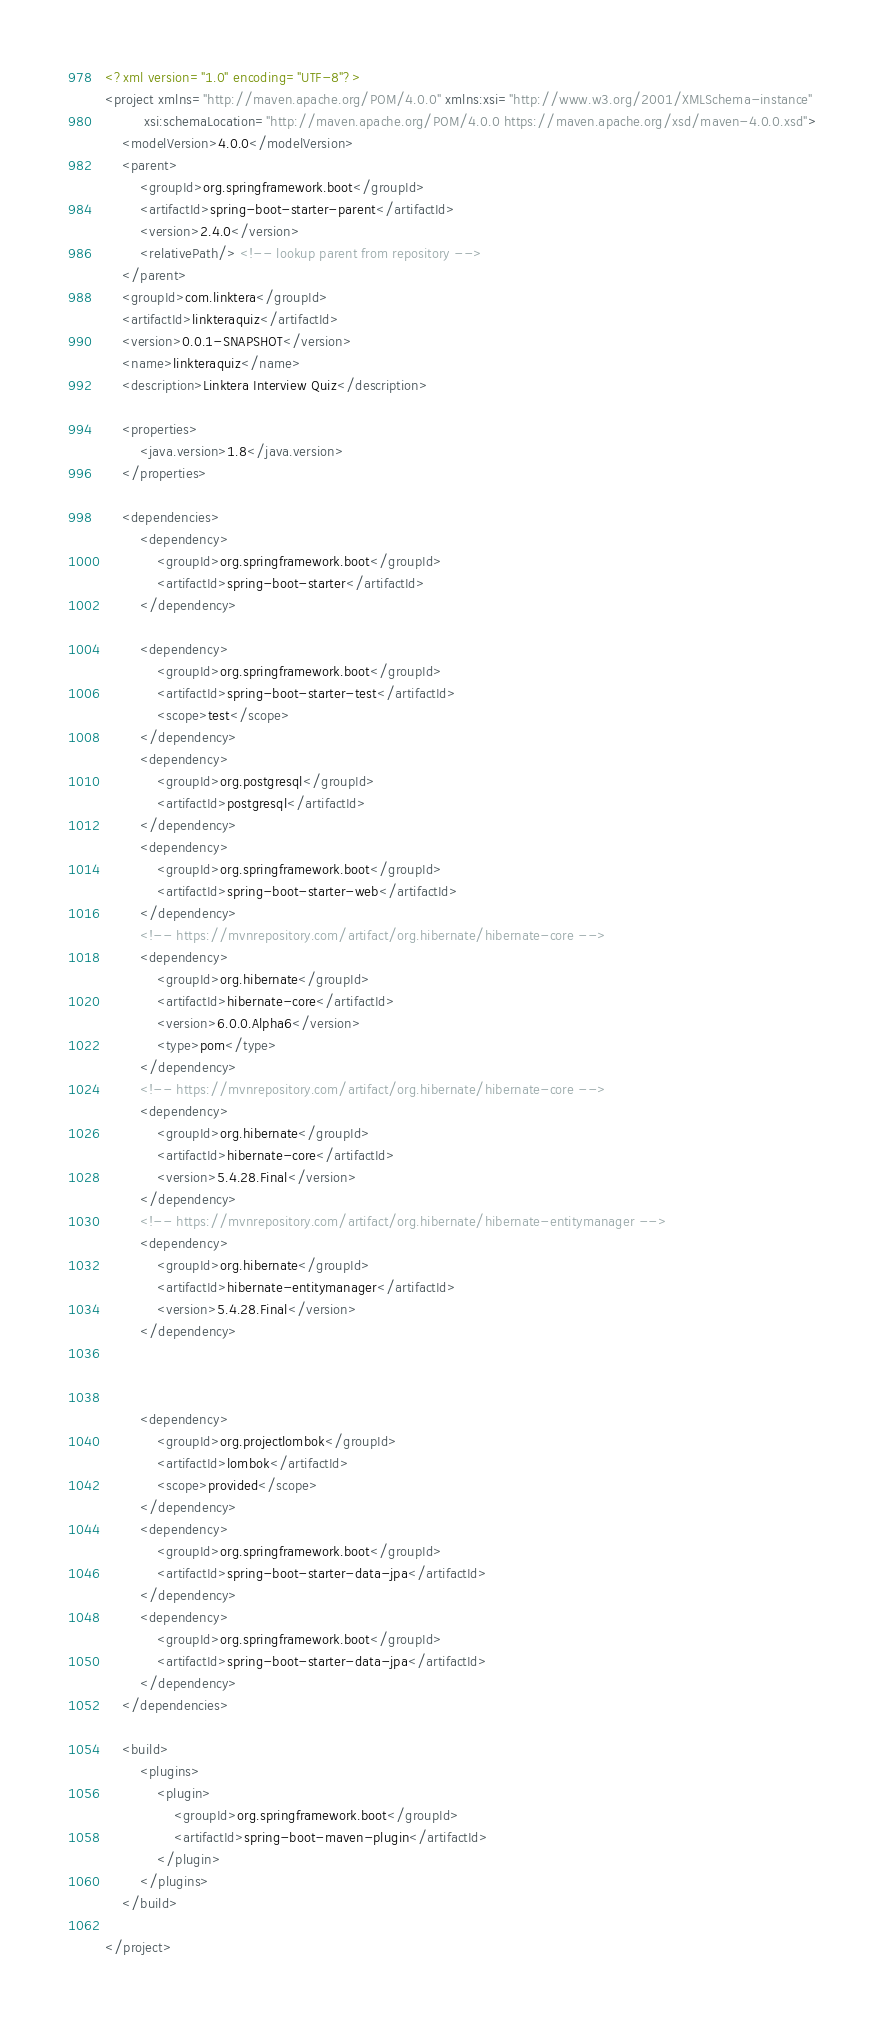<code> <loc_0><loc_0><loc_500><loc_500><_XML_><?xml version="1.0" encoding="UTF-8"?>
<project xmlns="http://maven.apache.org/POM/4.0.0" xmlns:xsi="http://www.w3.org/2001/XMLSchema-instance"
         xsi:schemaLocation="http://maven.apache.org/POM/4.0.0 https://maven.apache.org/xsd/maven-4.0.0.xsd">
    <modelVersion>4.0.0</modelVersion>
    <parent>
        <groupId>org.springframework.boot</groupId>
        <artifactId>spring-boot-starter-parent</artifactId>
        <version>2.4.0</version>
        <relativePath/> <!-- lookup parent from repository -->
    </parent>
    <groupId>com.linktera</groupId>
    <artifactId>linkteraquiz</artifactId>
    <version>0.0.1-SNAPSHOT</version>
    <name>linkteraquiz</name>
    <description>Linktera Interview Quiz</description>

    <properties>
        <java.version>1.8</java.version>
    </properties>

    <dependencies>
        <dependency>
            <groupId>org.springframework.boot</groupId>
            <artifactId>spring-boot-starter</artifactId>
        </dependency>

        <dependency>
            <groupId>org.springframework.boot</groupId>
            <artifactId>spring-boot-starter-test</artifactId>
            <scope>test</scope>
        </dependency>
        <dependency>
            <groupId>org.postgresql</groupId>
            <artifactId>postgresql</artifactId>
        </dependency>
        <dependency>
            <groupId>org.springframework.boot</groupId>
            <artifactId>spring-boot-starter-web</artifactId>
        </dependency>
        <!-- https://mvnrepository.com/artifact/org.hibernate/hibernate-core -->
        <dependency>
            <groupId>org.hibernate</groupId>
            <artifactId>hibernate-core</artifactId>
            <version>6.0.0.Alpha6</version>
            <type>pom</type>
        </dependency>
        <!-- https://mvnrepository.com/artifact/org.hibernate/hibernate-core -->
        <dependency>
            <groupId>org.hibernate</groupId>
            <artifactId>hibernate-core</artifactId>
            <version>5.4.28.Final</version>
        </dependency>
        <!-- https://mvnrepository.com/artifact/org.hibernate/hibernate-entitymanager -->
        <dependency>
            <groupId>org.hibernate</groupId>
            <artifactId>hibernate-entitymanager</artifactId>
            <version>5.4.28.Final</version>
        </dependency>



        <dependency>
            <groupId>org.projectlombok</groupId>
            <artifactId>lombok</artifactId>
            <scope>provided</scope>
        </dependency>
        <dependency>
            <groupId>org.springframework.boot</groupId>
            <artifactId>spring-boot-starter-data-jpa</artifactId>
        </dependency>
        <dependency>
            <groupId>org.springframework.boot</groupId>
            <artifactId>spring-boot-starter-data-jpa</artifactId>
        </dependency>
    </dependencies>

    <build>
        <plugins>
            <plugin>
                <groupId>org.springframework.boot</groupId>
                <artifactId>spring-boot-maven-plugin</artifactId>
            </plugin>
        </plugins>
    </build>

</project></code> 